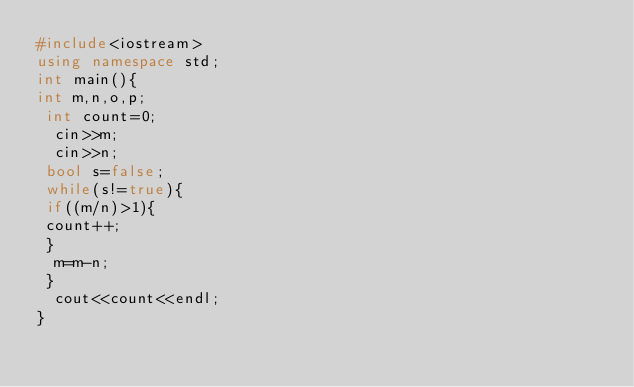Convert code to text. <code><loc_0><loc_0><loc_500><loc_500><_C++_>#include<iostream>
using namespace std;
int main(){
int m,n,o,p;
 int count=0;
  cin>>m;
  cin>>n;
 bool s=false;
 while(s!=true){
 if((m/n)>1){
 count++;
 }
  m=m-n;
 }
  cout<<count<<endl;
}</code> 